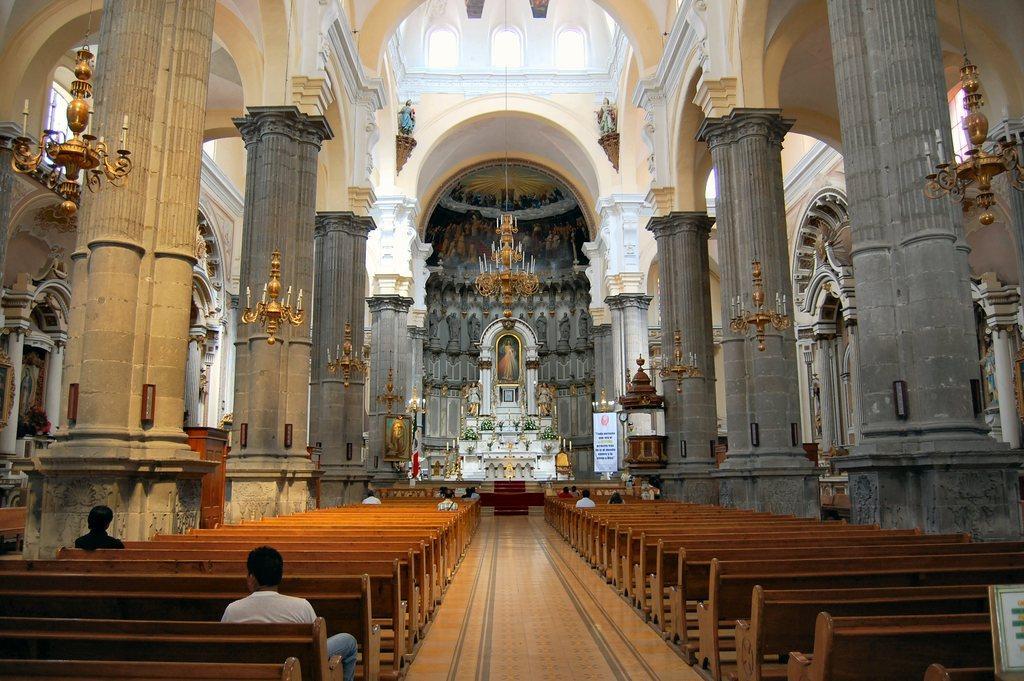Please provide a concise description of this image. In this image we can see a group of people sitting on benches placed on the ground. In the background, we can see some chandeliers, candles, photo frames on the wall, a banner with some text, a group of flowers, some pillars, statues and some windows. 